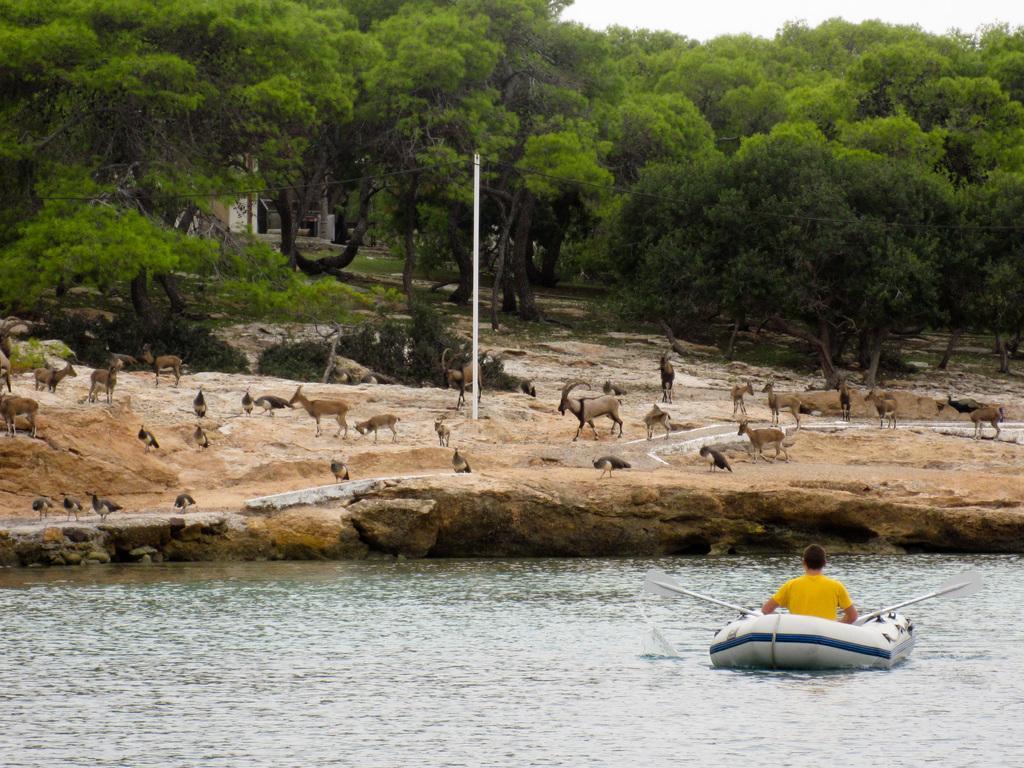How would you summarize this image in a sentence or two? In this image at the bottom there is a river, and in that river there is one boat. In the boat there is one person sitting, and in the background there are some animals, sand and some trees, pole and buildings. 